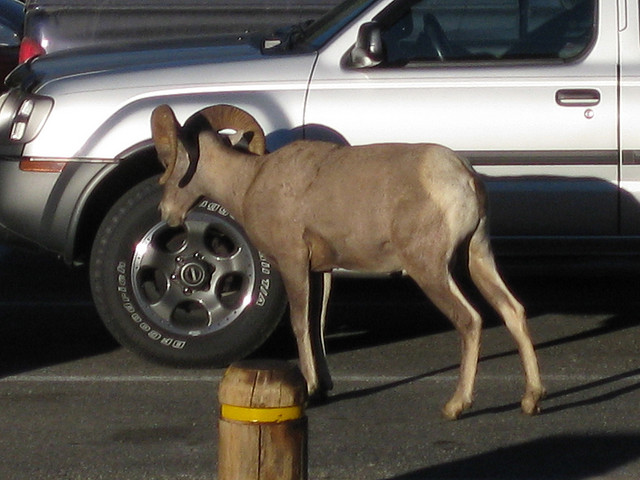How many sheep are there? The image actually shows a single donkey, not a sheep. It's standing next to a wooden post, in what appears to be a parking lot with a car in the background. 